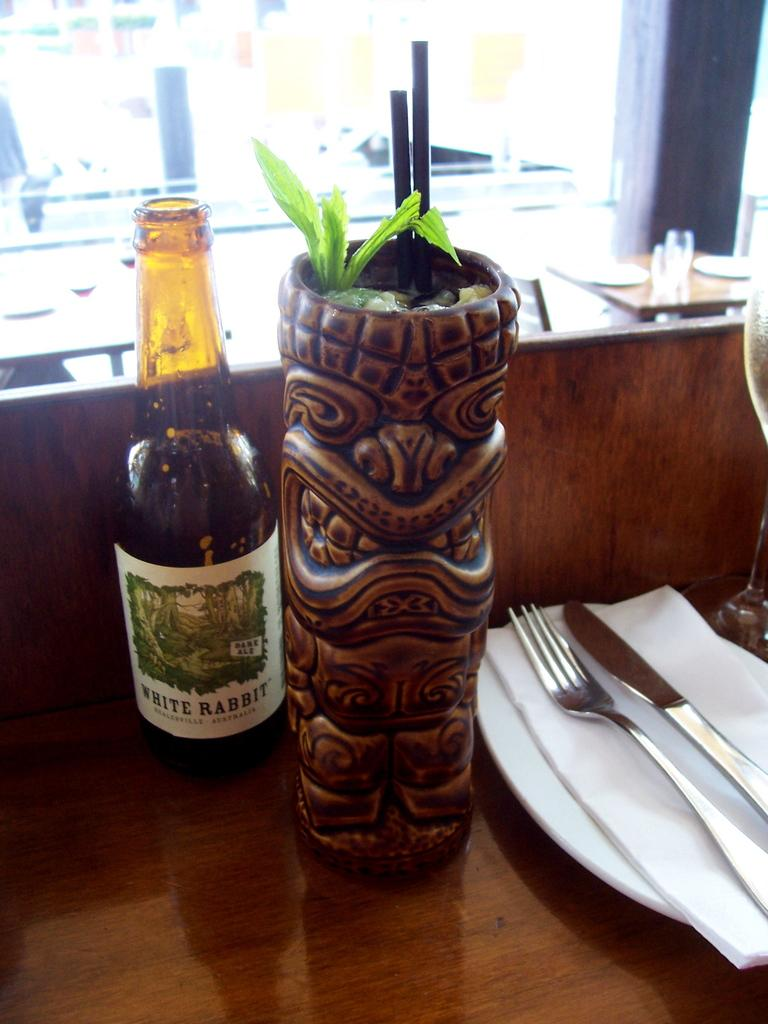What objects can be seen on the table in the image? There is a bottle, a flower vase, a plate, a tissue, a fork, and a knife on the table in the image. What is the purpose of the tissue on the table? The tissue might be used for wiping or cleaning purposes. What can be seen in the background of the image? In the background, there is a table, glasses, and a chair. How many cakes are being served on the table in the image? There are no cakes present in the image; only a bottle, a flower vase, a plate, a tissue, a fork, and a knife can be seen on the table. 